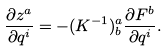Convert formula to latex. <formula><loc_0><loc_0><loc_500><loc_500>\frac { \partial z ^ { a } } { \partial q ^ { i } } = - ( K ^ { - 1 } ) ^ { a } _ { b } \frac { \partial F ^ { b } } { \partial q ^ { i } } .</formula> 